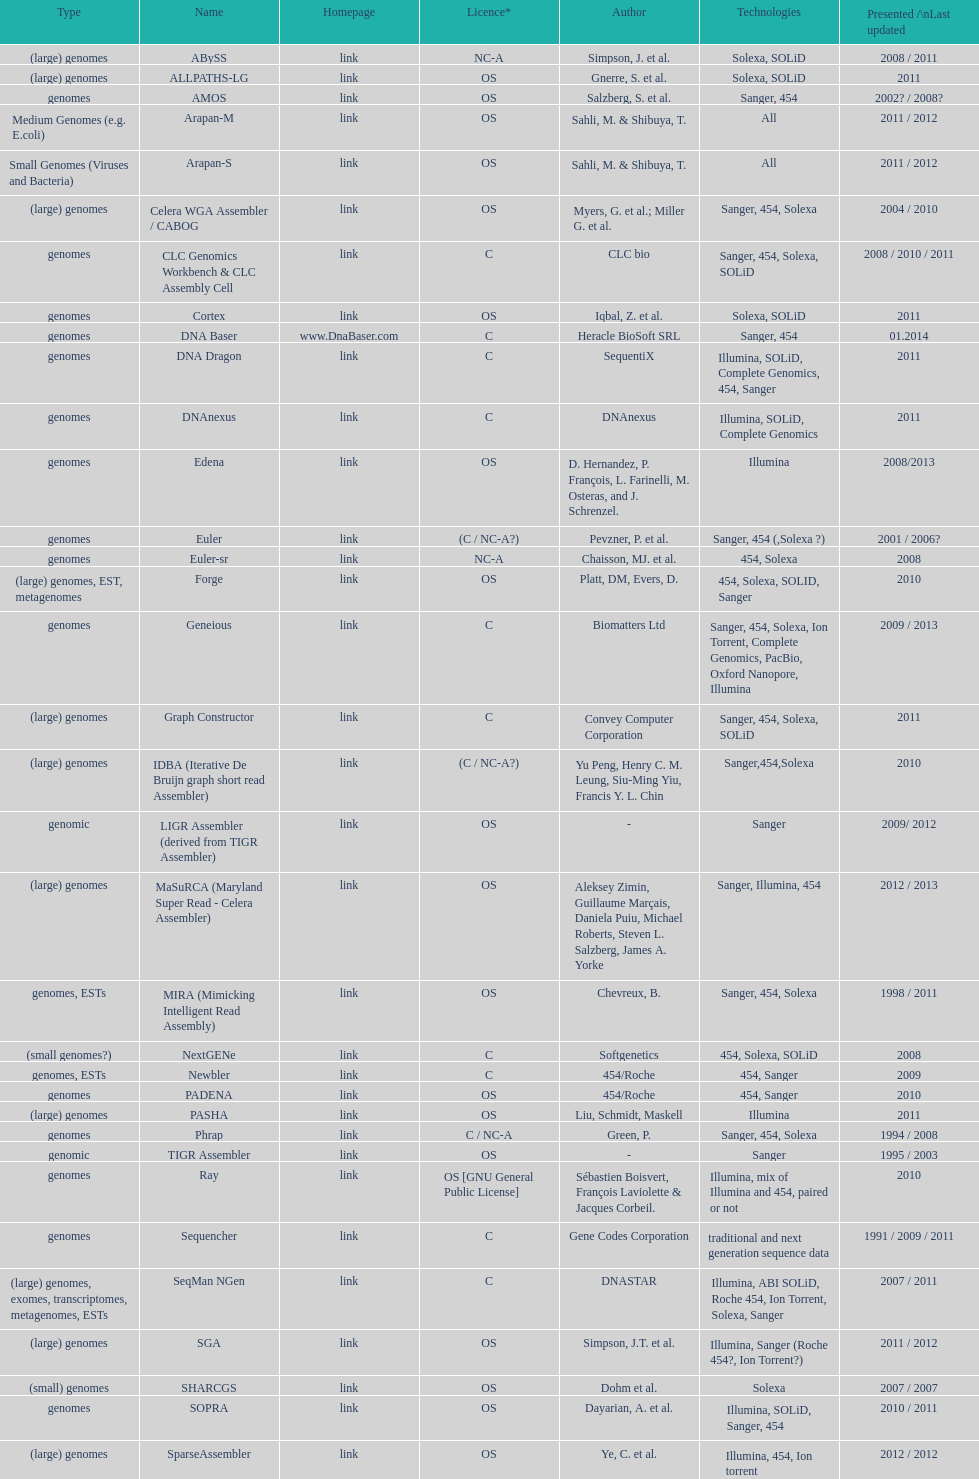What was the total number of times sahi, m. & shilbuya, t. listed as co-authors? 2. 